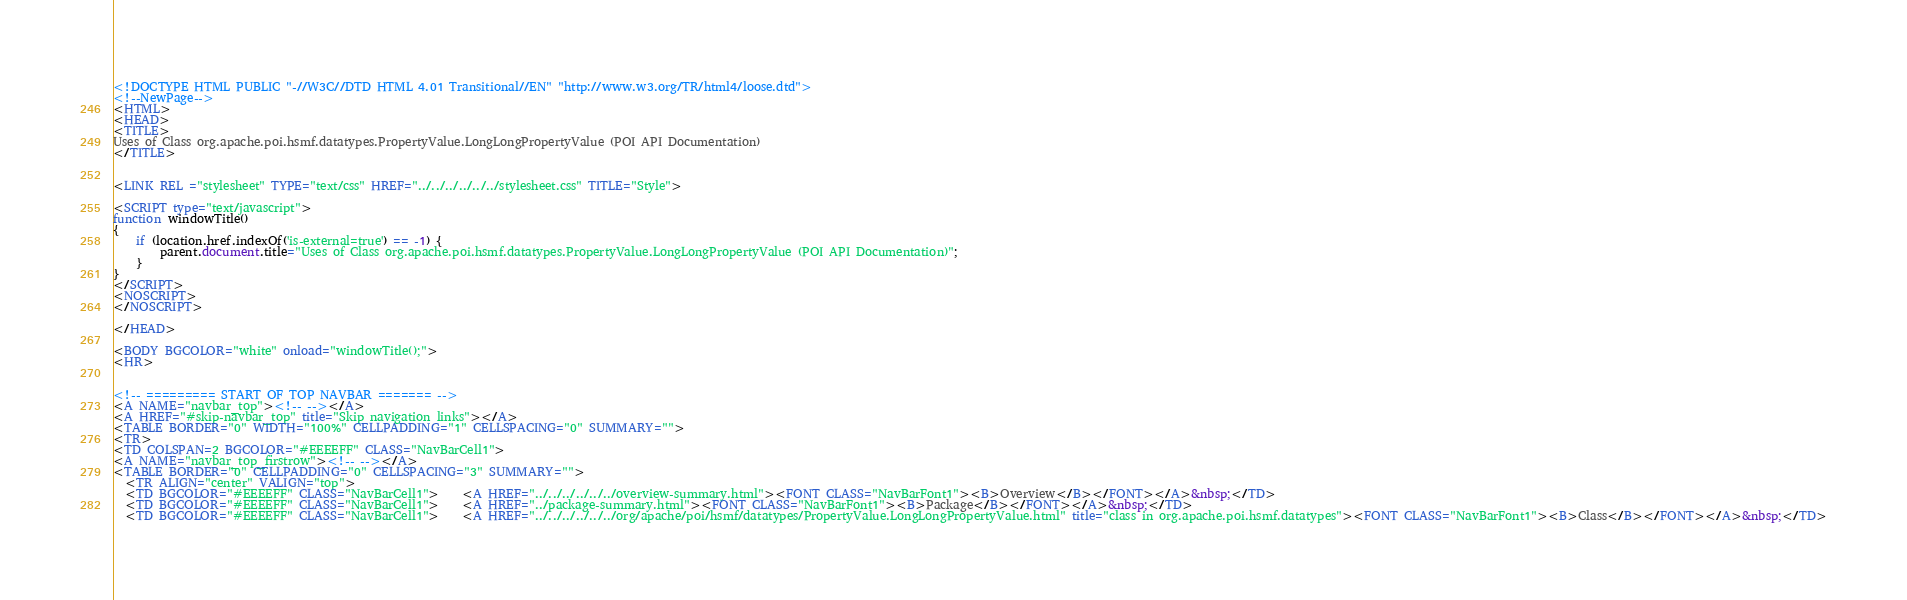Convert code to text. <code><loc_0><loc_0><loc_500><loc_500><_HTML_><!DOCTYPE HTML PUBLIC "-//W3C//DTD HTML 4.01 Transitional//EN" "http://www.w3.org/TR/html4/loose.dtd">
<!--NewPage-->
<HTML>
<HEAD>
<TITLE>
Uses of Class org.apache.poi.hsmf.datatypes.PropertyValue.LongLongPropertyValue (POI API Documentation)
</TITLE>


<LINK REL ="stylesheet" TYPE="text/css" HREF="../../../../../../stylesheet.css" TITLE="Style">

<SCRIPT type="text/javascript">
function windowTitle()
{
    if (location.href.indexOf('is-external=true') == -1) {
        parent.document.title="Uses of Class org.apache.poi.hsmf.datatypes.PropertyValue.LongLongPropertyValue (POI API Documentation)";
    }
}
</SCRIPT>
<NOSCRIPT>
</NOSCRIPT>

</HEAD>

<BODY BGCOLOR="white" onload="windowTitle();">
<HR>


<!-- ========= START OF TOP NAVBAR ======= -->
<A NAME="navbar_top"><!-- --></A>
<A HREF="#skip-navbar_top" title="Skip navigation links"></A>
<TABLE BORDER="0" WIDTH="100%" CELLPADDING="1" CELLSPACING="0" SUMMARY="">
<TR>
<TD COLSPAN=2 BGCOLOR="#EEEEFF" CLASS="NavBarCell1">
<A NAME="navbar_top_firstrow"><!-- --></A>
<TABLE BORDER="0" CELLPADDING="0" CELLSPACING="3" SUMMARY="">
  <TR ALIGN="center" VALIGN="top">
  <TD BGCOLOR="#EEEEFF" CLASS="NavBarCell1">    <A HREF="../../../../../../overview-summary.html"><FONT CLASS="NavBarFont1"><B>Overview</B></FONT></A>&nbsp;</TD>
  <TD BGCOLOR="#EEEEFF" CLASS="NavBarCell1">    <A HREF="../package-summary.html"><FONT CLASS="NavBarFont1"><B>Package</B></FONT></A>&nbsp;</TD>
  <TD BGCOLOR="#EEEEFF" CLASS="NavBarCell1">    <A HREF="../../../../../../org/apache/poi/hsmf/datatypes/PropertyValue.LongLongPropertyValue.html" title="class in org.apache.poi.hsmf.datatypes"><FONT CLASS="NavBarFont1"><B>Class</B></FONT></A>&nbsp;</TD></code> 